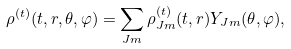Convert formula to latex. <formula><loc_0><loc_0><loc_500><loc_500>\rho ^ { ( t ) } ( t , r , \theta , \varphi ) = \sum _ { J m } \rho ^ { ( t ) } _ { J m } ( t , r ) Y _ { J m } ( \theta , \varphi ) ,</formula> 